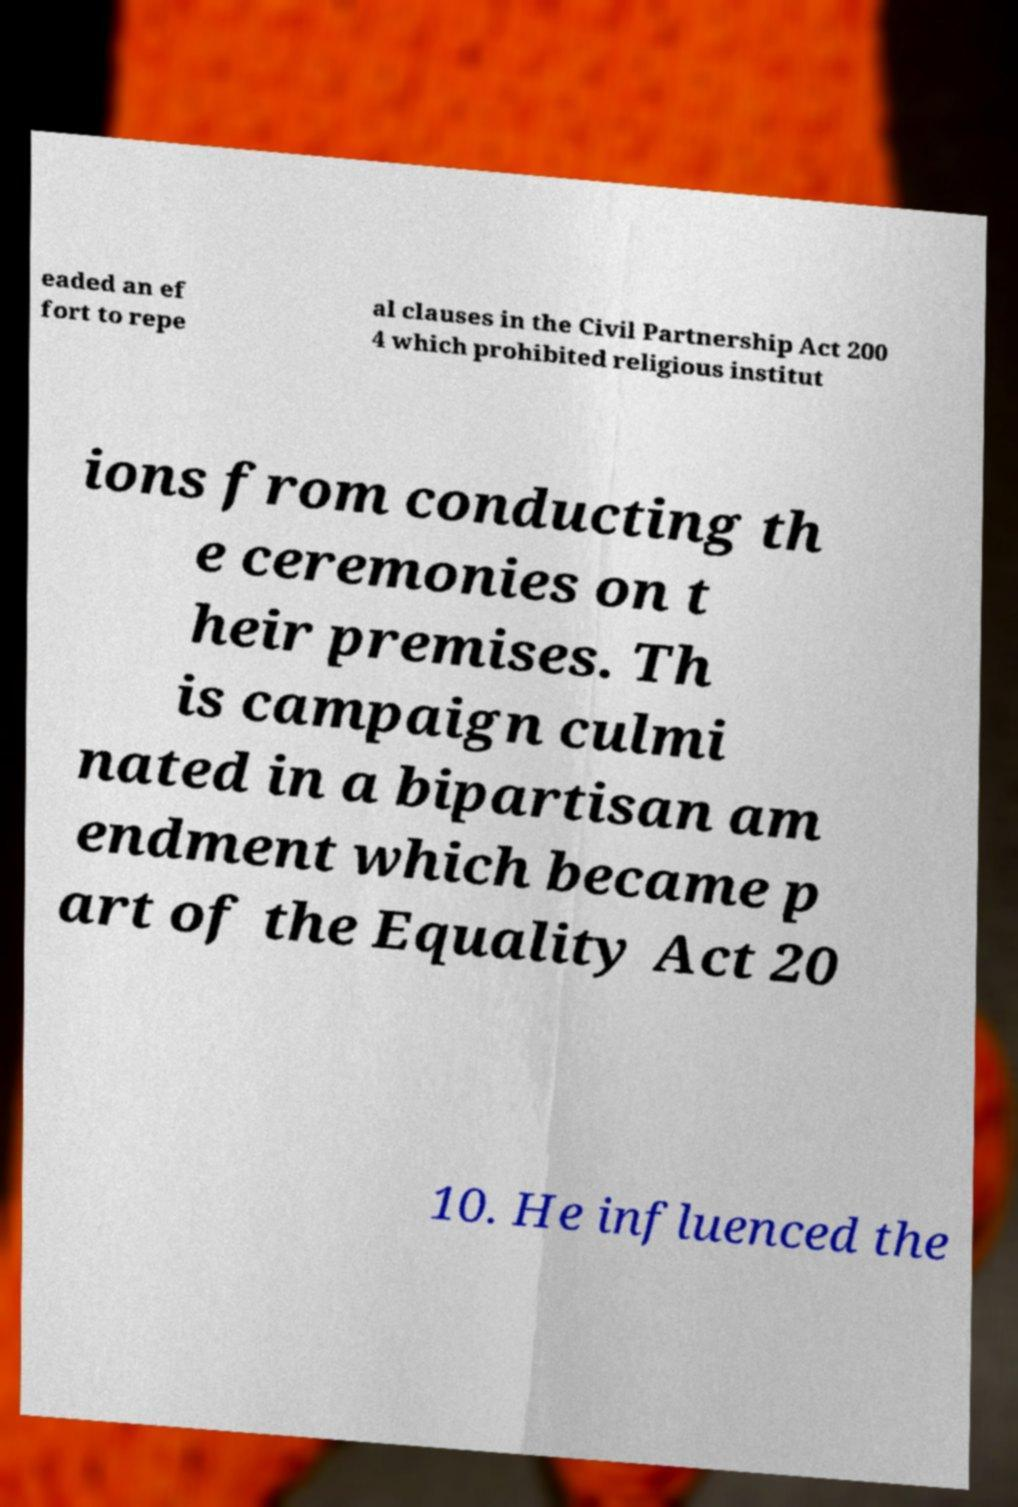For documentation purposes, I need the text within this image transcribed. Could you provide that? eaded an ef fort to repe al clauses in the Civil Partnership Act 200 4 which prohibited religious institut ions from conducting th e ceremonies on t heir premises. Th is campaign culmi nated in a bipartisan am endment which became p art of the Equality Act 20 10. He influenced the 